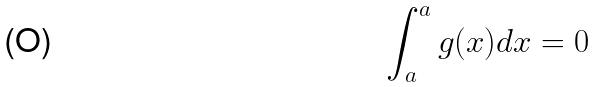<formula> <loc_0><loc_0><loc_500><loc_500>\int _ { a } ^ { a } g ( x ) d x = 0</formula> 